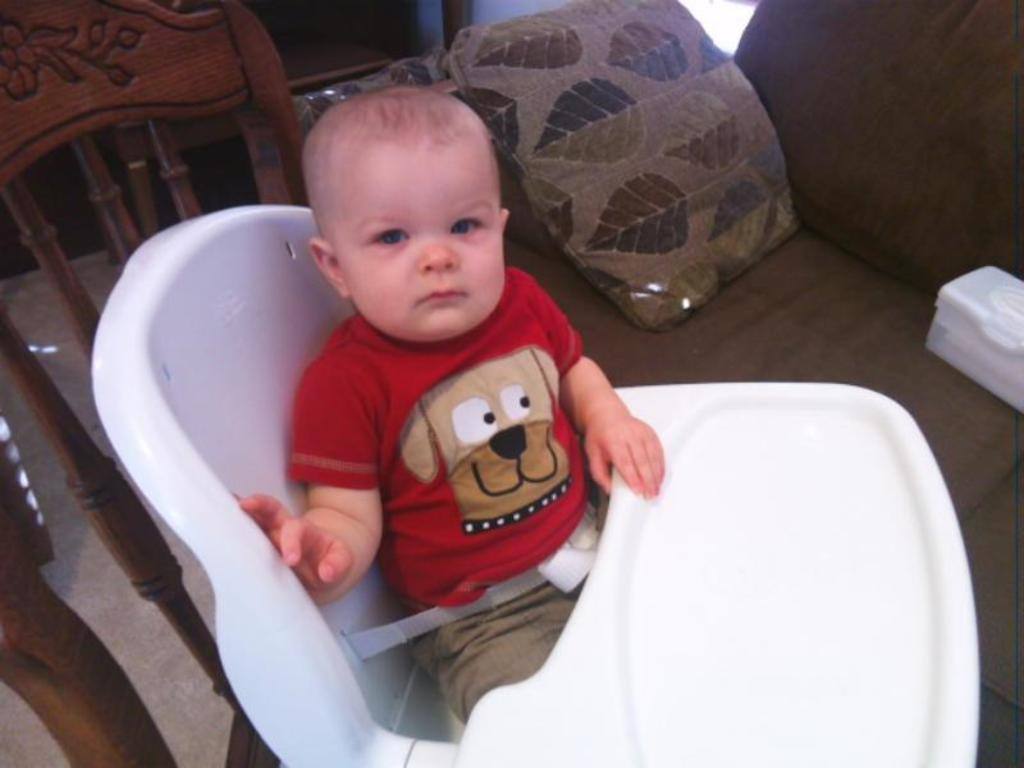Who is the main subject in the image? There is a boy in the image. What is the boy doing in the image? The boy is sitting on a chair. What can be seen in the background of the image? There is a couch, a pillow, and a box in the background of the image. Where is the arm located in the image? There is no specific mention of an arm in the image. The main subject is a boy sitting on a chair, but the focus is not on any specific body part. 